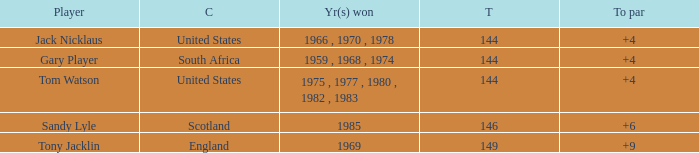What was England's total? 149.0. 